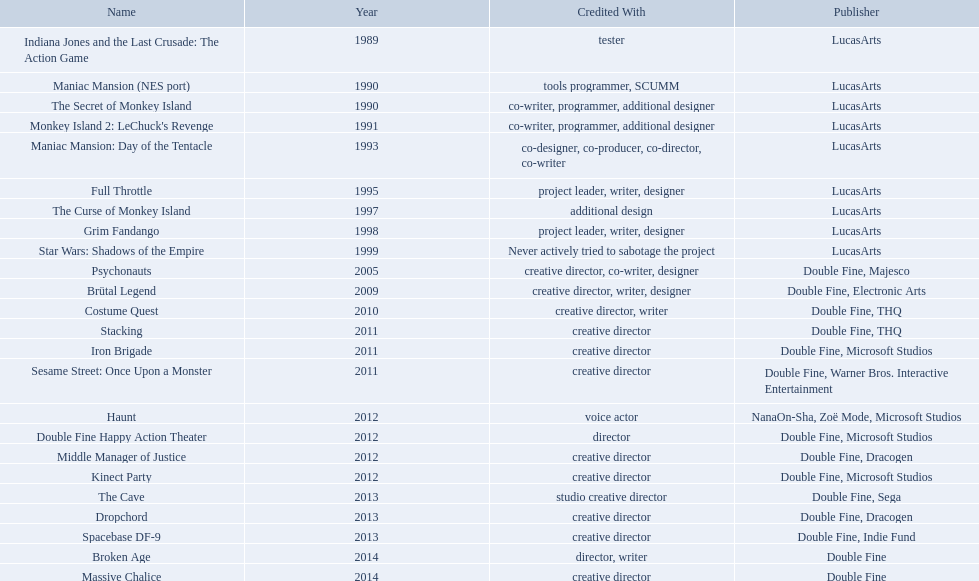What game name has tim schafer been involved with? Indiana Jones and the Last Crusade: The Action Game, Maniac Mansion (NES port), The Secret of Monkey Island, Monkey Island 2: LeChuck's Revenge, Maniac Mansion: Day of the Tentacle, Full Throttle, The Curse of Monkey Island, Grim Fandango, Star Wars: Shadows of the Empire, Psychonauts, Brütal Legend, Costume Quest, Stacking, Iron Brigade, Sesame Street: Once Upon a Monster, Haunt, Double Fine Happy Action Theater, Middle Manager of Justice, Kinect Party, The Cave, Dropchord, Spacebase DF-9, Broken Age, Massive Chalice. Which game has credit with just creative director? Creative director, creative director, creative director, creative director, creative director, creative director, creative director, creative director. Which games have the above and warner bros. interactive entertainment as publisher? Sesame Street: Once Upon a Monster. Which productions did tim schafer work on that were published in part by double fine? Psychonauts, Brütal Legend, Costume Quest, Stacking, Iron Brigade, Sesame Street: Once Upon a Monster, Double Fine Happy Action Theater, Middle Manager of Justice, Kinect Party, The Cave, Dropchord, Spacebase DF-9, Broken Age, Massive Chalice. Which of these was he a creative director? Psychonauts, Brütal Legend, Costume Quest, Stacking, Iron Brigade, Sesame Street: Once Upon a Monster, Middle Manager of Justice, Kinect Party, The Cave, Dropchord, Spacebase DF-9, Massive Chalice. Which of those were in 2011? Stacking, Iron Brigade, Sesame Street: Once Upon a Monster. What was the only one of these to be co published by warner brothers? Sesame Street: Once Upon a Monster. Which game is acknowledged to have a creative director? Creative director, co-writer, designer, creative director, writer, designer, creative director, writer, creative director, creative director, creative director, creative director, creative director, creative director, creative director, creative director. From these games, which one also lists warner bros. interactive as the creative director? Sesame Street: Once Upon a Monster. Which works was tim schafer involved in that were partly distributed by double fine? Psychonauts, Brütal Legend, Costume Quest, Stacking, Iron Brigade, Sesame Street: Once Upon a Monster, Double Fine Happy Action Theater, Middle Manager of Justice, Kinect Party, The Cave, Dropchord, Spacebase DF-9, Broken Age, Massive Chalice. In which of these instances was he a creative director? Psychonauts, Brütal Legend, Costume Quest, Stacking, Iron Brigade, Sesame Street: Once Upon a Monster, Middle Manager of Justice, Kinect Party, The Cave, Dropchord, Spacebase DF-9, Massive Chalice. Which of those happened in 2011? Stacking, Iron Brigade, Sesame Street: Once Upon a Monster. What was the exclusive collaboration with warner brothers among these? Sesame Street: Once Upon a Monster. In which game title has tim schafer participated? Indiana Jones and the Last Crusade: The Action Game, Maniac Mansion (NES port), The Secret of Monkey Island, Monkey Island 2: LeChuck's Revenge, Maniac Mansion: Day of the Tentacle, Full Throttle, The Curse of Monkey Island, Grim Fandango, Star Wars: Shadows of the Empire, Psychonauts, Brütal Legend, Costume Quest, Stacking, Iron Brigade, Sesame Street: Once Upon a Monster, Haunt, Double Fine Happy Action Theater, Middle Manager of Justice, Kinect Party, The Cave, Dropchord, Spacebase DF-9, Broken Age, Massive Chalice. Which game attributes him solely as the creative director? Creative director, creative director, creative director, creative director, creative director, creative director, creative director, creative director. Which of these games also have warner bros. interactive entertainment as their publisher? Sesame Street: Once Upon a Monster. What game is associated with tim schafer's involvement? Indiana Jones and the Last Crusade: The Action Game, Maniac Mansion (NES port), The Secret of Monkey Island, Monkey Island 2: LeChuck's Revenge, Maniac Mansion: Day of the Tentacle, Full Throttle, The Curse of Monkey Island, Grim Fandango, Star Wars: Shadows of the Empire, Psychonauts, Brütal Legend, Costume Quest, Stacking, Iron Brigade, Sesame Street: Once Upon a Monster, Haunt, Double Fine Happy Action Theater, Middle Manager of Justice, Kinect Party, The Cave, Dropchord, Spacebase DF-9, Broken Age, Massive Chalice. In which game does he hold the exclusive title of creative director? Creative director, creative director, creative director, creative director, creative director, creative director, creative director, creative director. Which games fit these descriptions and have warner bros. interactive entertainment as the publisher? Sesame Street: Once Upon a Monster. 